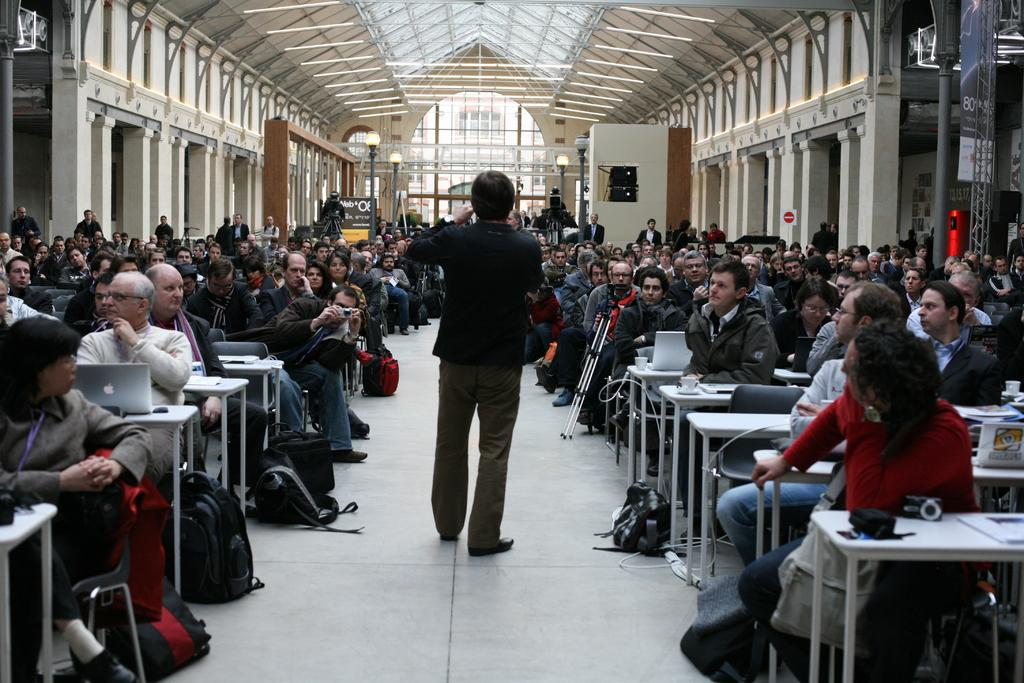What are the people in the room doing? The people in the room are operating laptops. Can you describe the man's position in the room? There is a man standing in the middle of the room. What type of distribution system is being used for the laptops in the image? There is no mention of a distribution system for the laptops in the image; people are simply operating them. Can you tell me how many pockets the man standing in the middle of the room has? The image does not provide enough detail to determine the number of pockets the man has. 